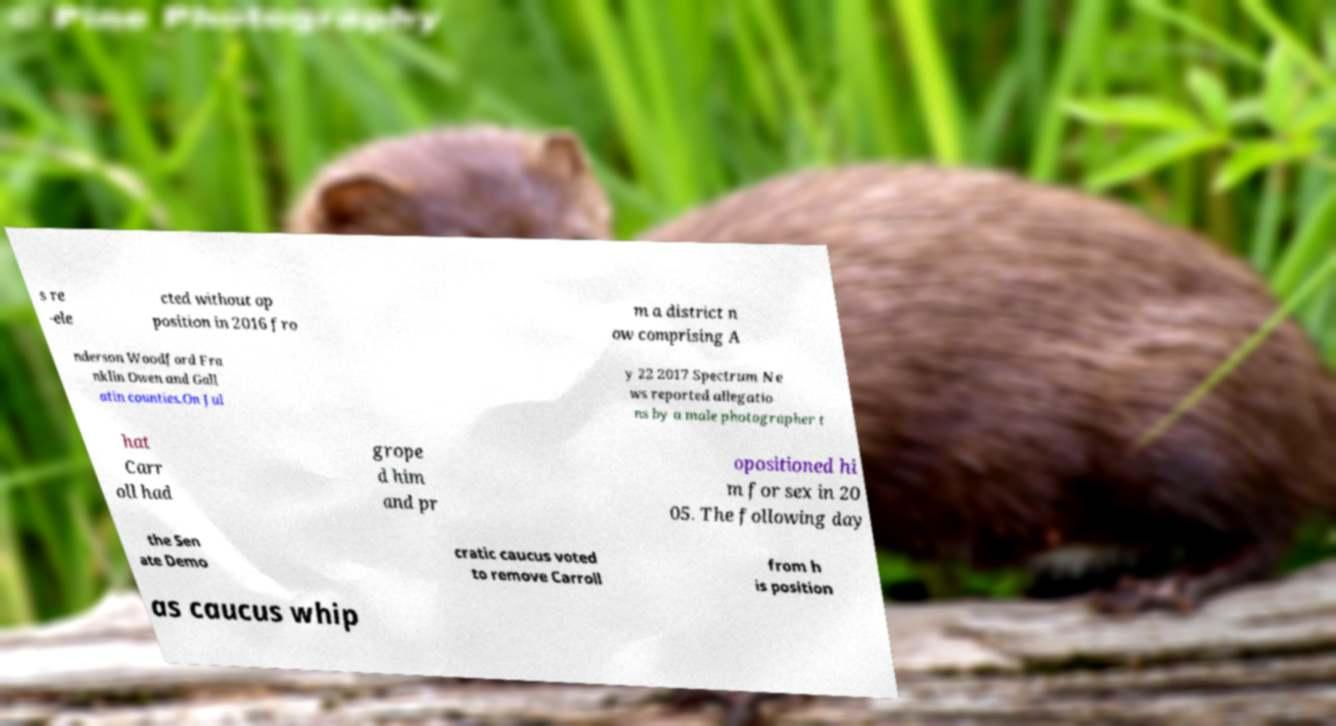Can you read and provide the text displayed in the image?This photo seems to have some interesting text. Can you extract and type it out for me? s re -ele cted without op position in 2016 fro m a district n ow comprising A nderson Woodford Fra nklin Owen and Gall atin counties.On Jul y 22 2017 Spectrum Ne ws reported allegatio ns by a male photographer t hat Carr oll had grope d him and pr opositioned hi m for sex in 20 05. The following day the Sen ate Demo cratic caucus voted to remove Carroll from h is position as caucus whip 